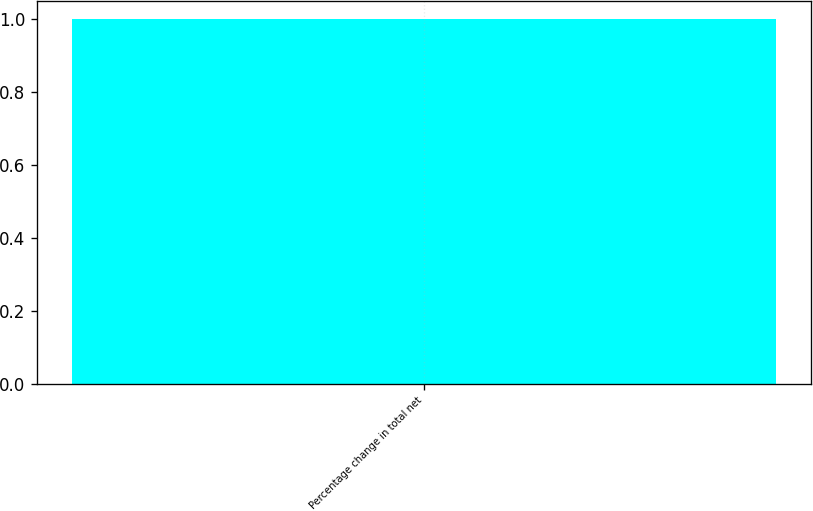Convert chart. <chart><loc_0><loc_0><loc_500><loc_500><bar_chart><fcel>Percentage change in total net<nl><fcel>1<nl></chart> 